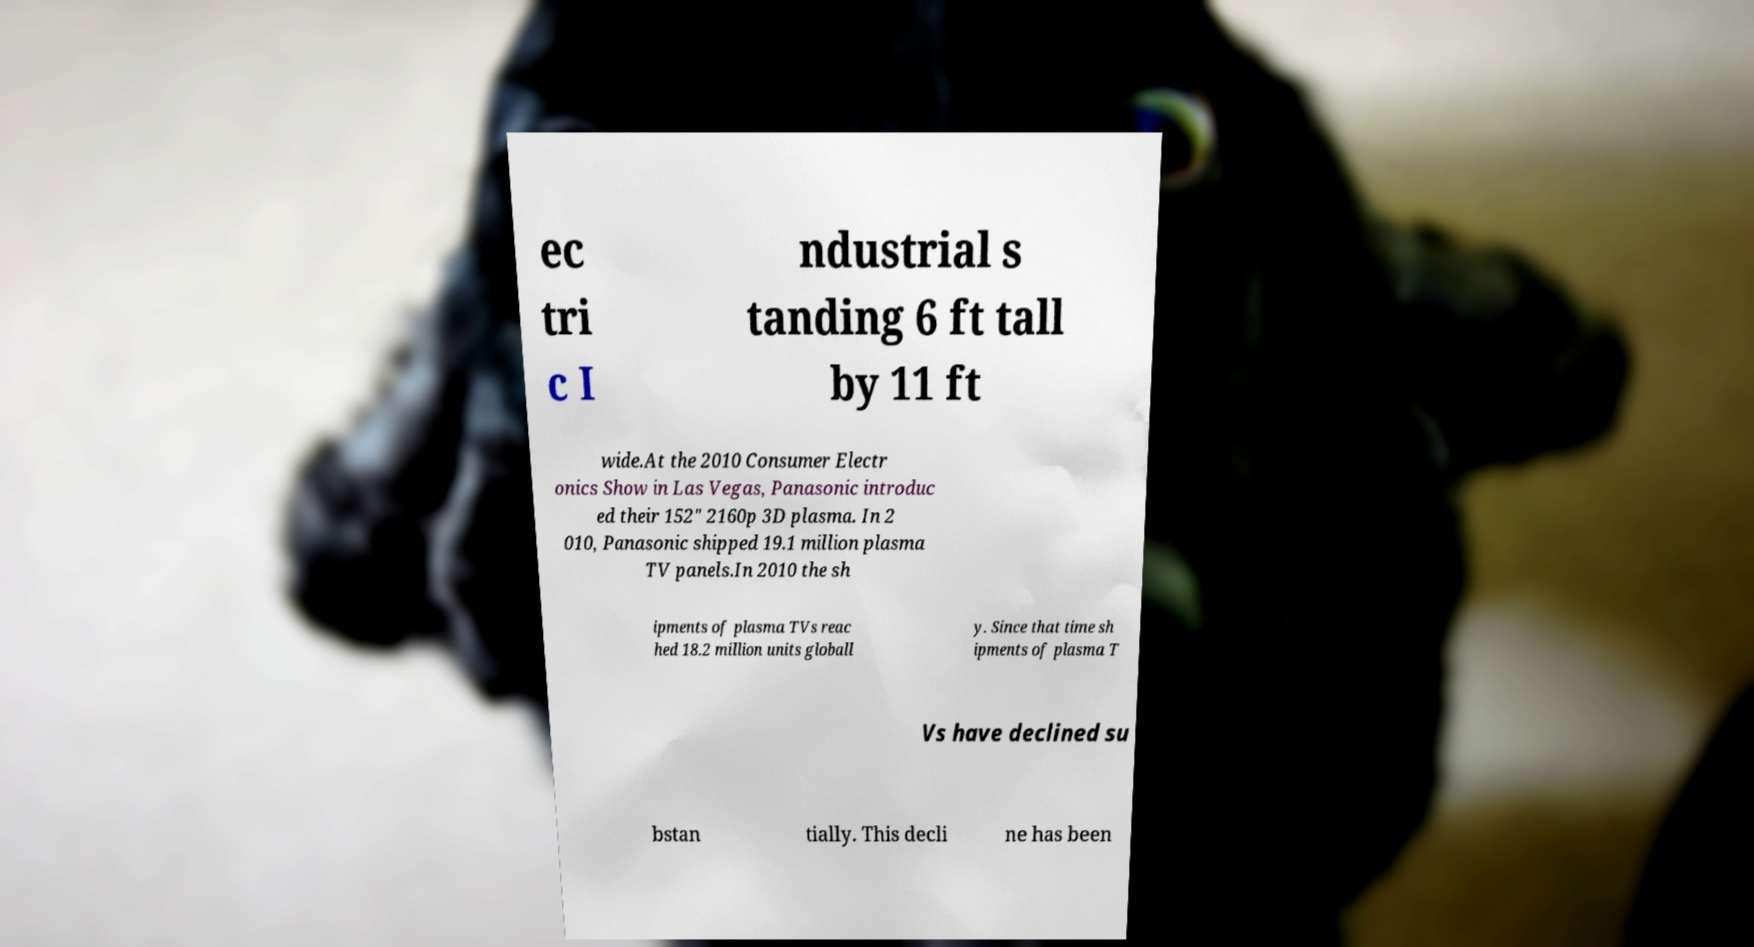Please read and relay the text visible in this image. What does it say? ec tri c I ndustrial s tanding 6 ft tall by 11 ft wide.At the 2010 Consumer Electr onics Show in Las Vegas, Panasonic introduc ed their 152" 2160p 3D plasma. In 2 010, Panasonic shipped 19.1 million plasma TV panels.In 2010 the sh ipments of plasma TVs reac hed 18.2 million units globall y. Since that time sh ipments of plasma T Vs have declined su bstan tially. This decli ne has been 